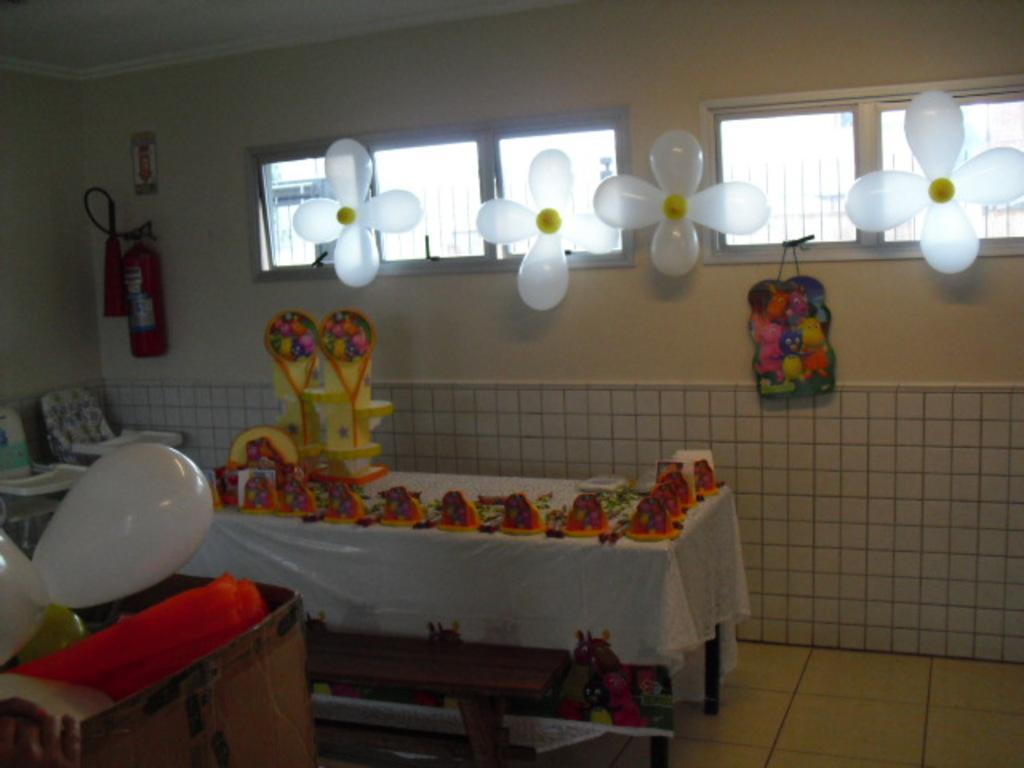Describe this image in one or two sentences. In this image, I can see the food items and few other objects on a table, which is covered with a cloth. At the bottom of the image, I can see a wooden bench on the floor. At the bottom left corner of the image, there are balloons and few other objects in a cardboard box. On the left side of the image, there are chairs with the trays. I can see a fire extinguisher and a poster attached to the wall. In the background, there are balloons attached to the windows and I can see a toy bag hanging to a window. 